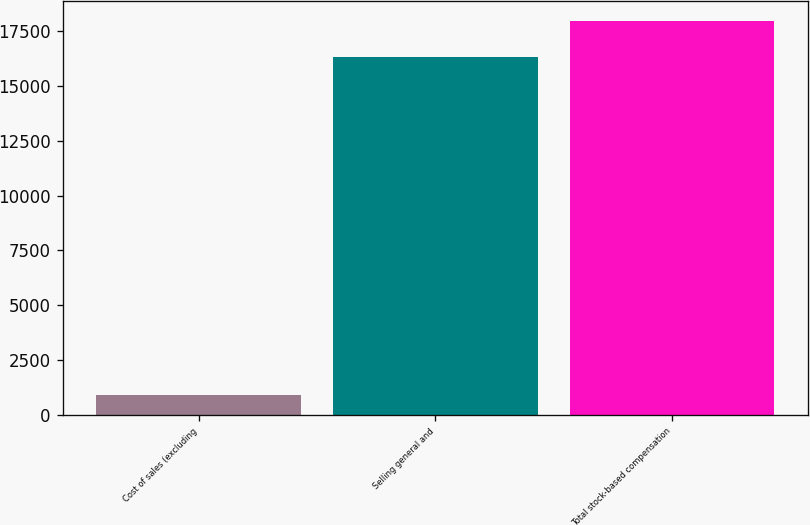Convert chart. <chart><loc_0><loc_0><loc_500><loc_500><bar_chart><fcel>Cost of sales (excluding<fcel>Selling general and<fcel>Total stock-based compensation<nl><fcel>914<fcel>16336<fcel>17969.6<nl></chart> 